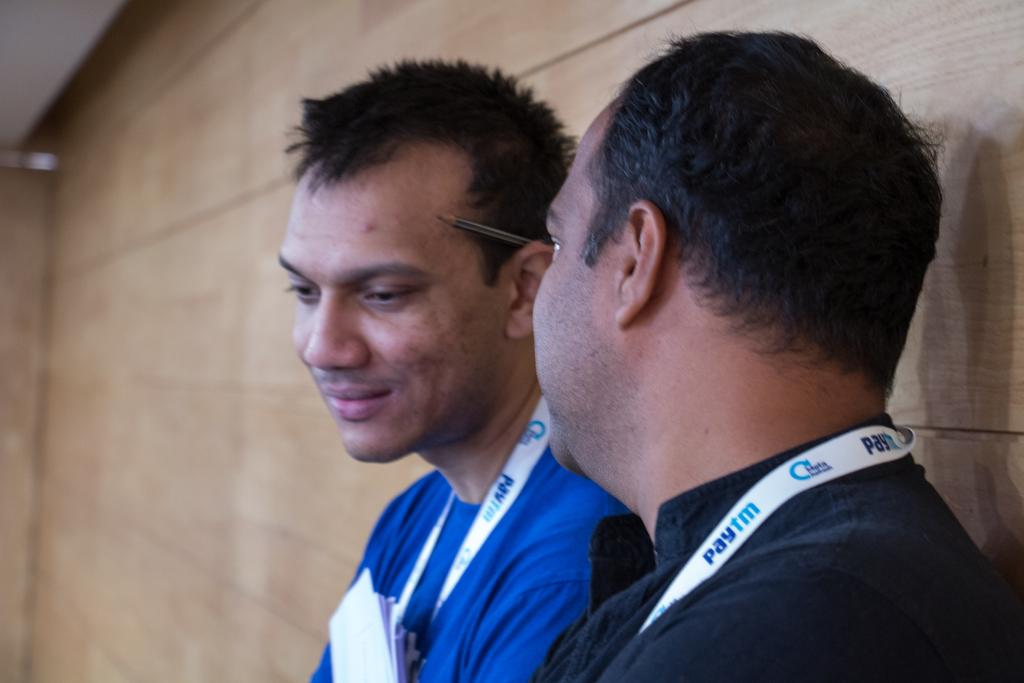Provide a one-sentence caption for the provided image. Man talking to another man both wearing a necklace that says paytm. 